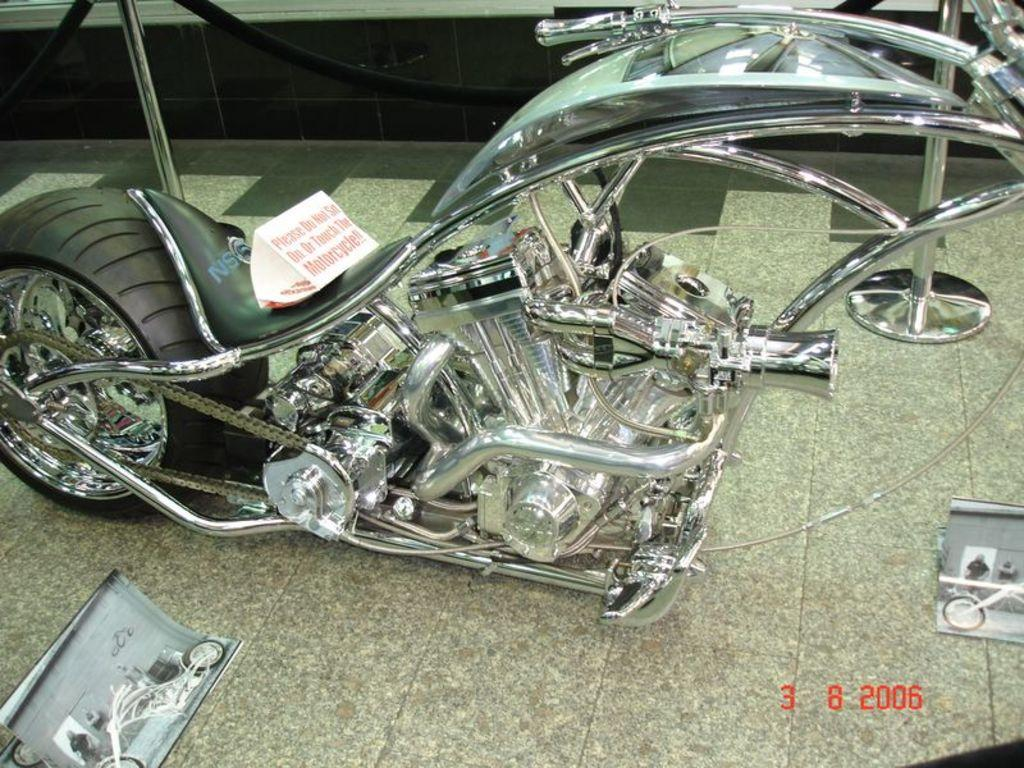What is the main subject of the image? The main subject of the image is a motorcycle. Can you describe the position of the motorcycle in the image? The motorcycle is on the ground in the image. What can be seen in the background of the image? There are poles visible in the background of the image. How many friends are accompanying the motorcyclist on their journey in the image? There are no friends or journey depicted in the image; it only shows a motorcycle on the ground with poles in the background. 